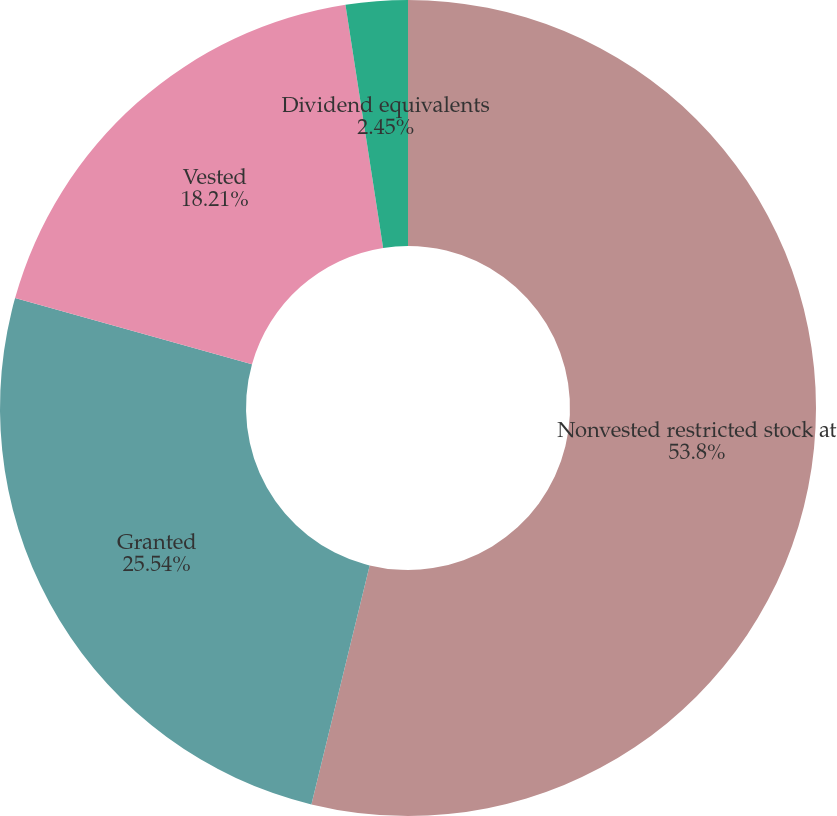Convert chart to OTSL. <chart><loc_0><loc_0><loc_500><loc_500><pie_chart><fcel>Nonvested restricted stock at<fcel>Granted<fcel>Vested<fcel>Dividend equivalents<nl><fcel>53.81%<fcel>25.54%<fcel>18.21%<fcel>2.45%<nl></chart> 